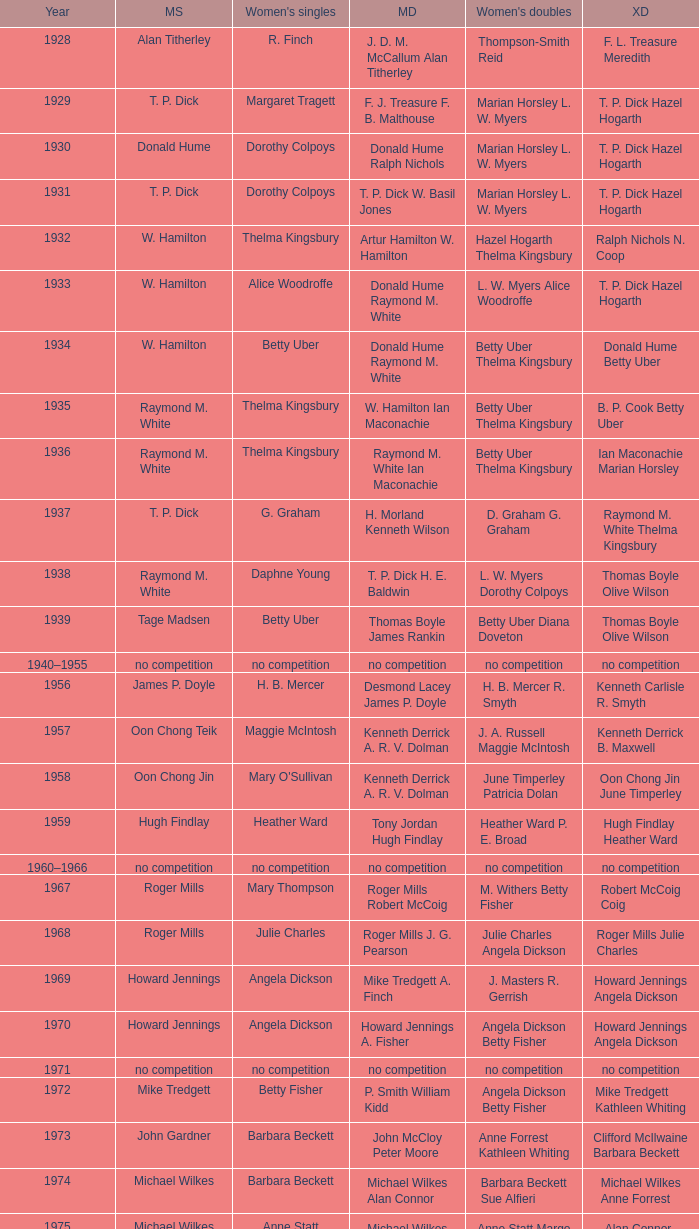Who won the Women's singles, in the year that Raymond M. White won the Men's singles and that W. Hamilton Ian Maconachie won the Men's doubles? Thelma Kingsbury. 